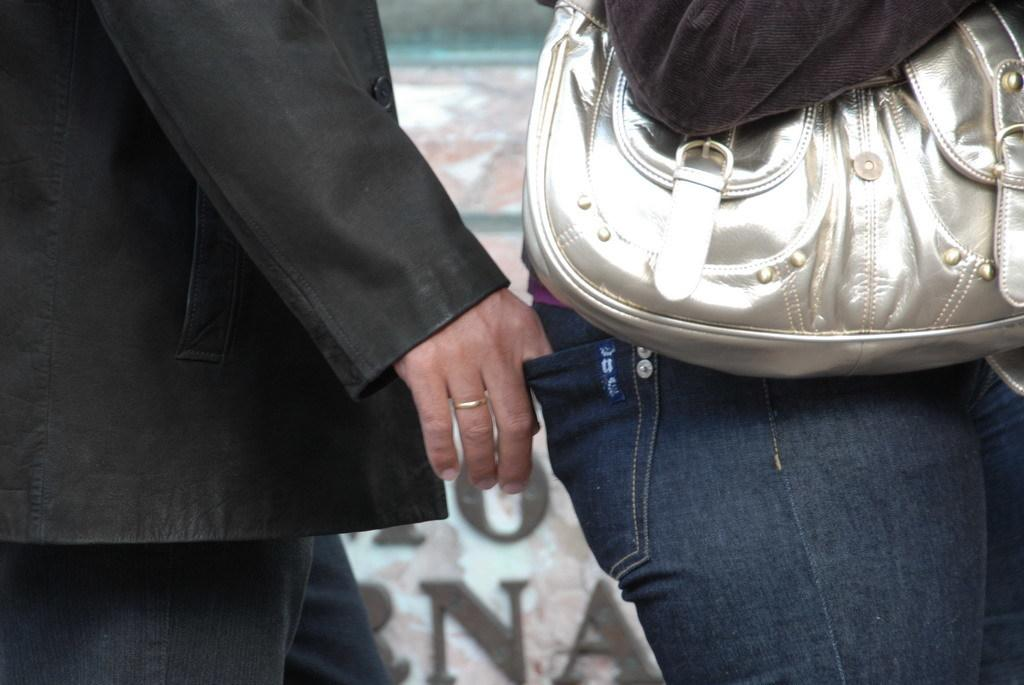Who is the main subject in the image? There is a person in the image. What is the person wearing? The person is wearing a coat and jeans. What action is the person taking in the image? The person is taking something out of a woman's pocket. What accessory is the woman wearing in the image? The woman is wearing a handbag. What is the texture of the manager's shirt in the image? There is no manager present in the image, and therefore no shirt or texture to describe. 